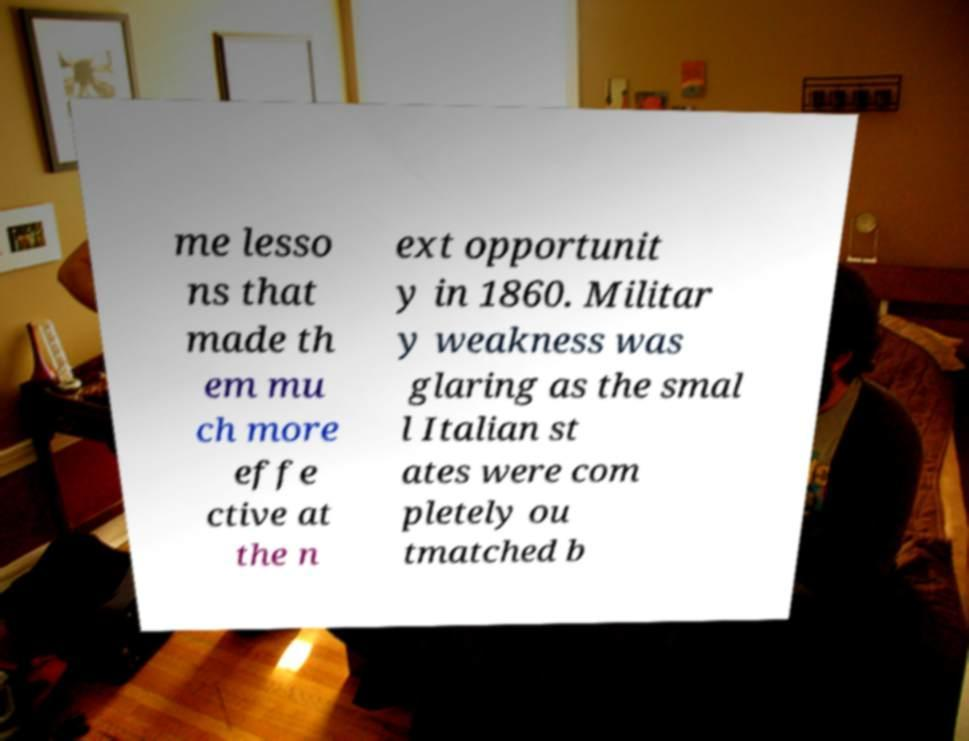Could you assist in decoding the text presented in this image and type it out clearly? me lesso ns that made th em mu ch more effe ctive at the n ext opportunit y in 1860. Militar y weakness was glaring as the smal l Italian st ates were com pletely ou tmatched b 